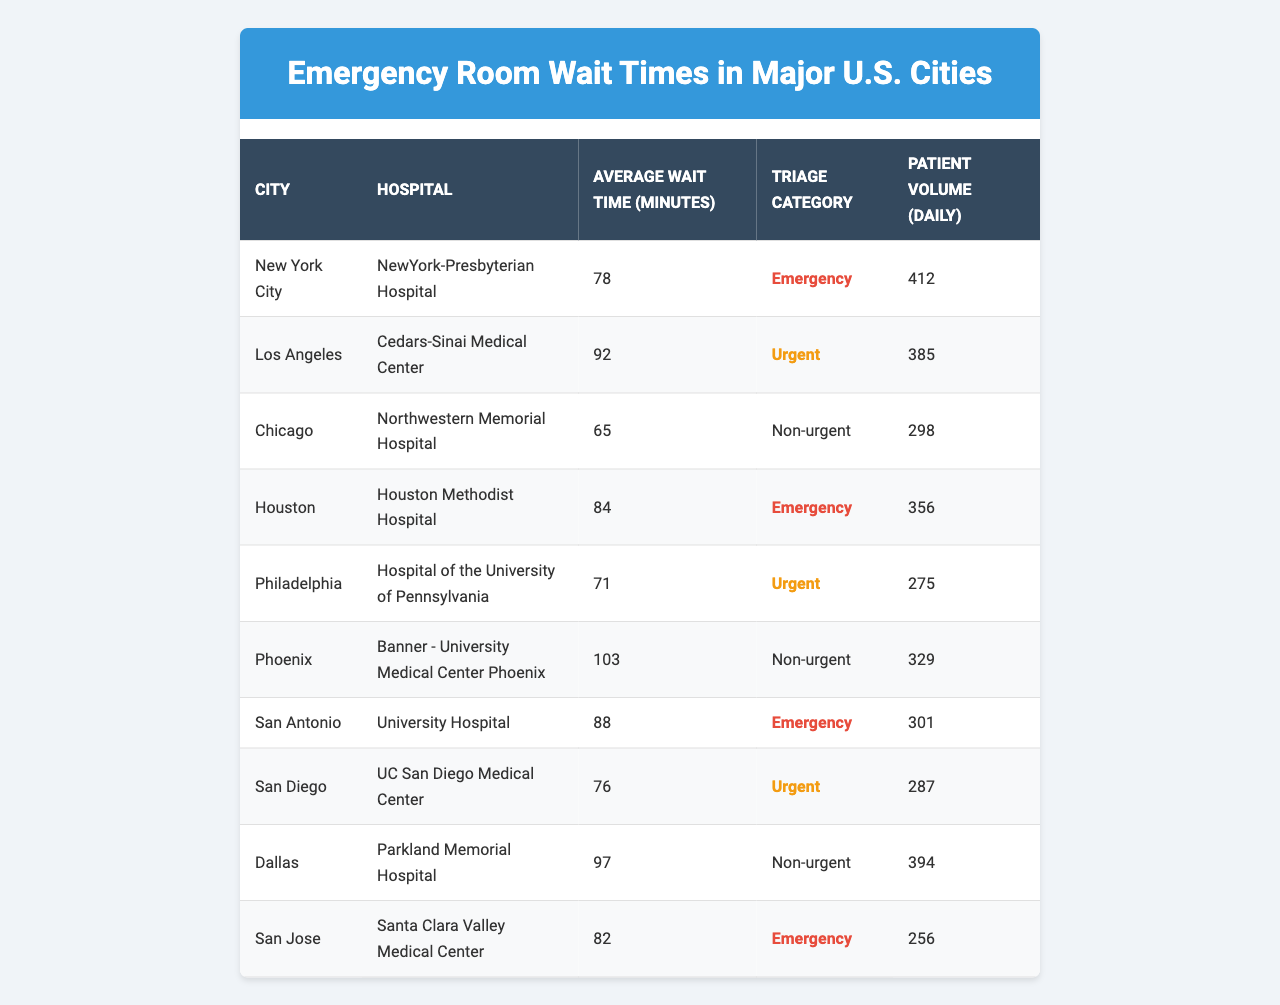What is the average wait time in New York City? According to the table, the average wait time in New York City at NewYork-Presbyterian Hospital is listed as 78 minutes.
Answer: 78 minutes Which city has the longest average wait time for emergency rooms? By examining the table, Phoenix has the longest wait time of 103 minutes for reactions categorized as non-urgent.
Answer: Phoenix True or False: San Antonio has a lower average wait time than Houston. The average wait time for San Antonio is 88 minutes, while for Houston, it is 84 minutes. Since 88 is greater than 84, the statement is false.
Answer: False What is the total patient volume from the hospitals listed in Chicago, Philadelphia, and Dallas? The patient volumes for these cities are 298 (Chicago), 275 (Philadelphia), and 394 (Dallas). Adding them together gives: 298 + 275 + 394 = 967.
Answer: 967 Which hospital in San Diego has an urgent triage category, and what is its average wait time? The hospital in San Diego is UC San Diego Medical Center, which has an average wait time of 76 minutes and is classified as urgent.
Answer: UC San Diego Medical Center, 76 minutes What is the difference between the average wait times for hospitals in Los Angeles and Chicago? For Los Angeles, the average wait time is 92 minutes, and for Chicago, it is 65 minutes. The difference is calculated as 92 - 65 = 27 minutes.
Answer: 27 minutes How many cities listed have emergency triage categories? The cities with emergency triage categories are New York City, Houston, San Antonio, and San Jose, totaling four cities.
Answer: 4 cities If we consider the average wait times for all the cities listed, what is the average wait time? The average wait time can be calculated first by adding all average wait times: 78 + 92 + 65 + 84 + 71 + 103 + 88 + 76 + 97 + 82 = 936. Then, divide by the number of cities (10): 936/10 = 93.6 minutes.
Answer: 93.6 minutes Which city has the lowest patient volume, and what is that value? By reviewing the table, Philadelphia has the lowest patient volume at 275 patients daily.
Answer: 275 patients Is the average wait time for urgent cases in Philadelphia lower than in San Diego? Philadelphia's average wait time is 71 minutes, while San Diego's is 76 minutes. Since 71 is less than 76, the statement is true.
Answer: True 